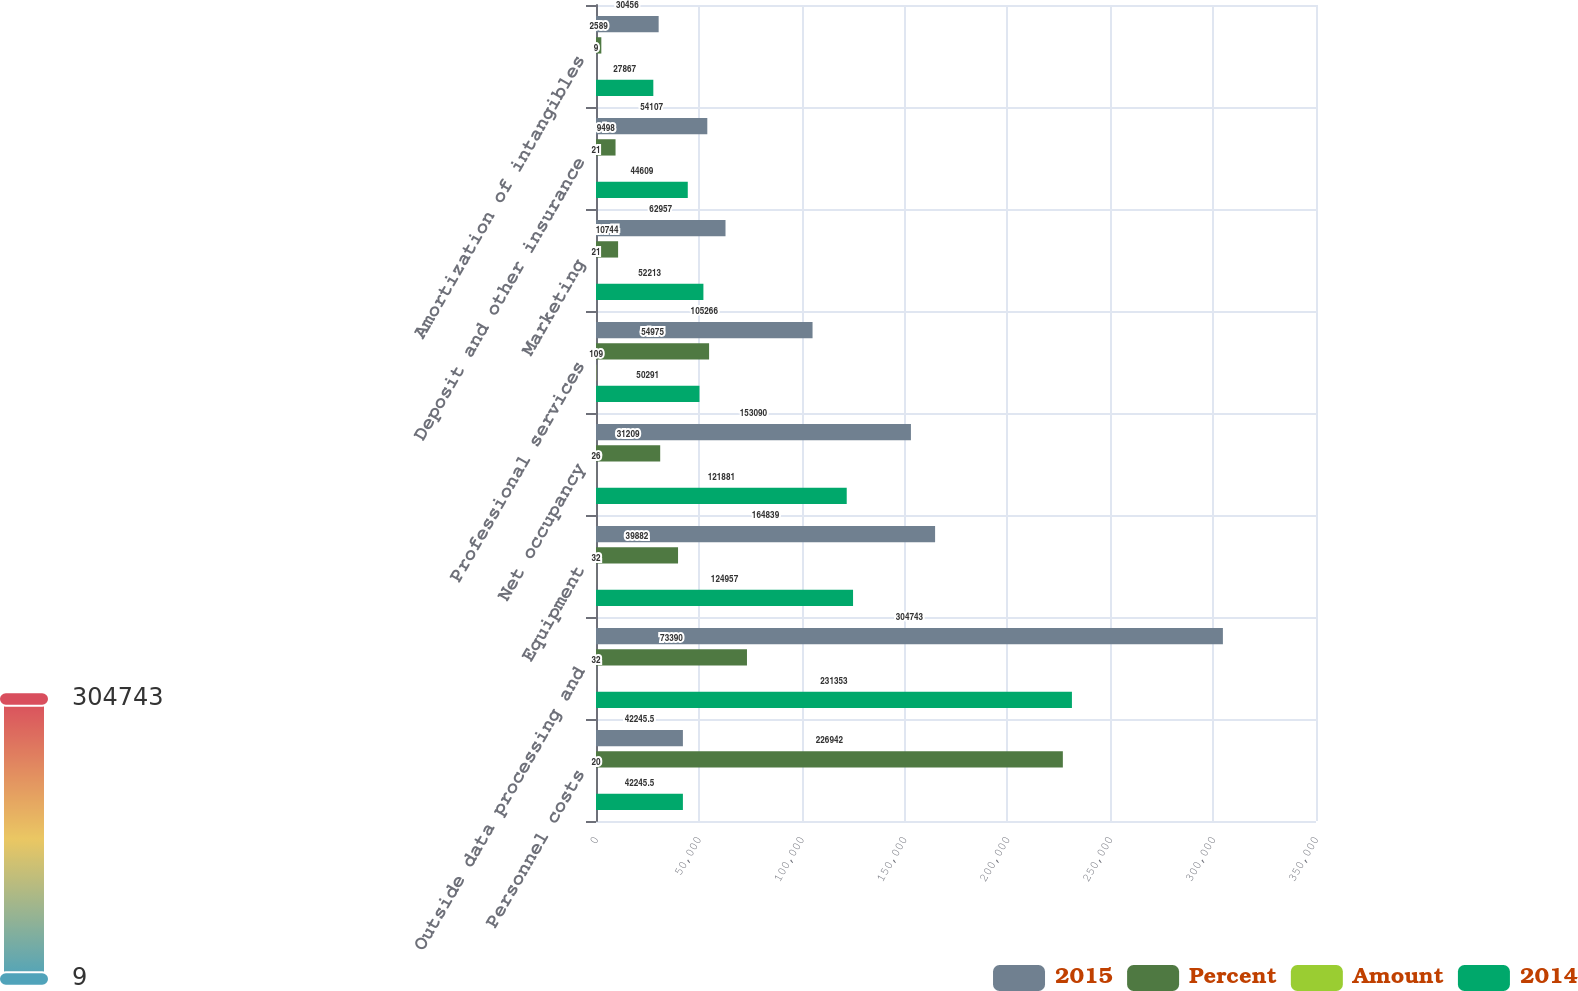Convert chart. <chart><loc_0><loc_0><loc_500><loc_500><stacked_bar_chart><ecel><fcel>Personnel costs<fcel>Outside data processing and<fcel>Equipment<fcel>Net occupancy<fcel>Professional services<fcel>Marketing<fcel>Deposit and other insurance<fcel>Amortization of intangibles<nl><fcel>2015<fcel>42245.5<fcel>304743<fcel>164839<fcel>153090<fcel>105266<fcel>62957<fcel>54107<fcel>30456<nl><fcel>Percent<fcel>226942<fcel>73390<fcel>39882<fcel>31209<fcel>54975<fcel>10744<fcel>9498<fcel>2589<nl><fcel>Amount<fcel>20<fcel>32<fcel>32<fcel>26<fcel>109<fcel>21<fcel>21<fcel>9<nl><fcel>2014<fcel>42245.5<fcel>231353<fcel>124957<fcel>121881<fcel>50291<fcel>52213<fcel>44609<fcel>27867<nl></chart> 